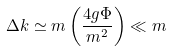Convert formula to latex. <formula><loc_0><loc_0><loc_500><loc_500>\Delta k \simeq m \left ( \frac { 4 g \Phi } { m ^ { 2 } } \right ) \ll m</formula> 